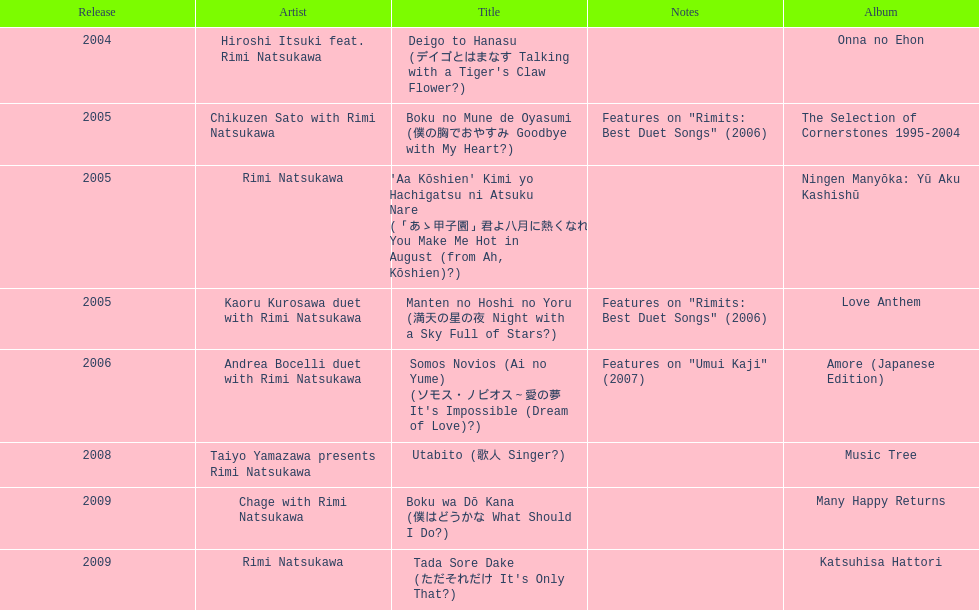What is the number of albums released with the artist rimi natsukawa? 8. 